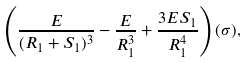<formula> <loc_0><loc_0><loc_500><loc_500>\left ( \frac { E } { ( R _ { 1 } + S _ { 1 } ) ^ { 3 } } - \frac { E } { R _ { 1 } ^ { 3 } } + \frac { 3 E S _ { 1 } } { R _ { 1 } ^ { 4 } } \right ) ( \sigma ) ,</formula> 